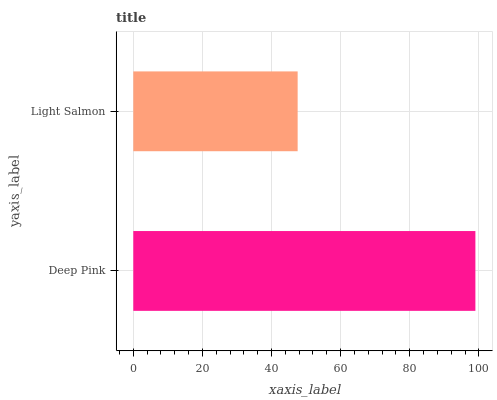Is Light Salmon the minimum?
Answer yes or no. Yes. Is Deep Pink the maximum?
Answer yes or no. Yes. Is Light Salmon the maximum?
Answer yes or no. No. Is Deep Pink greater than Light Salmon?
Answer yes or no. Yes. Is Light Salmon less than Deep Pink?
Answer yes or no. Yes. Is Light Salmon greater than Deep Pink?
Answer yes or no. No. Is Deep Pink less than Light Salmon?
Answer yes or no. No. Is Deep Pink the high median?
Answer yes or no. Yes. Is Light Salmon the low median?
Answer yes or no. Yes. Is Light Salmon the high median?
Answer yes or no. No. Is Deep Pink the low median?
Answer yes or no. No. 